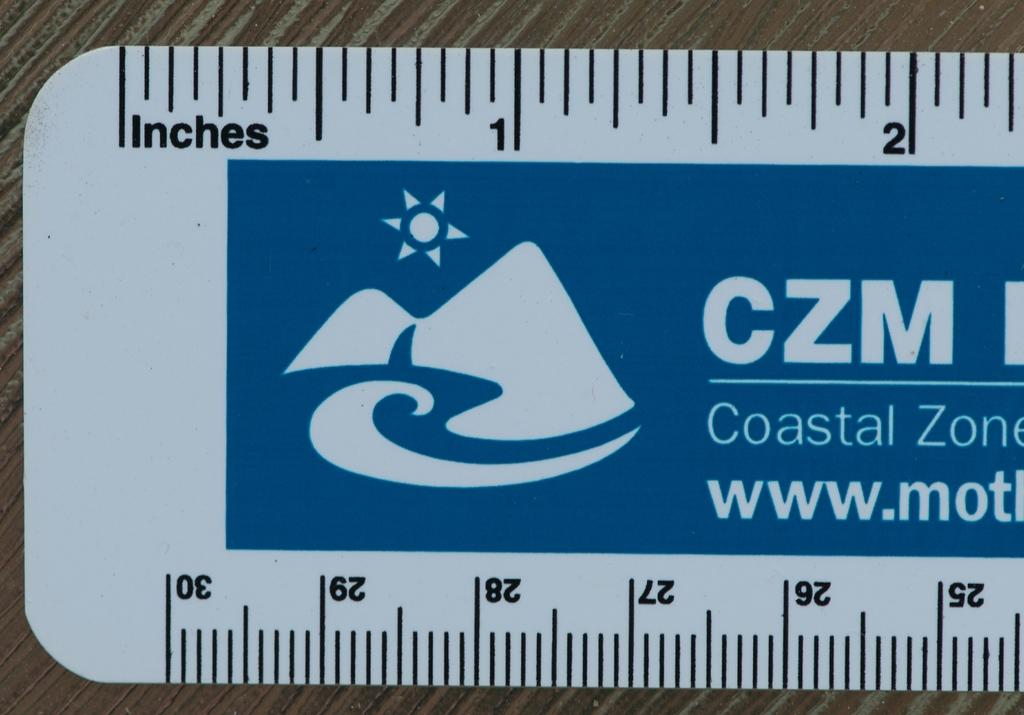<image>
Create a compact narrative representing the image presented. The end of a ruler with an advertisement for CZM in the middle. 